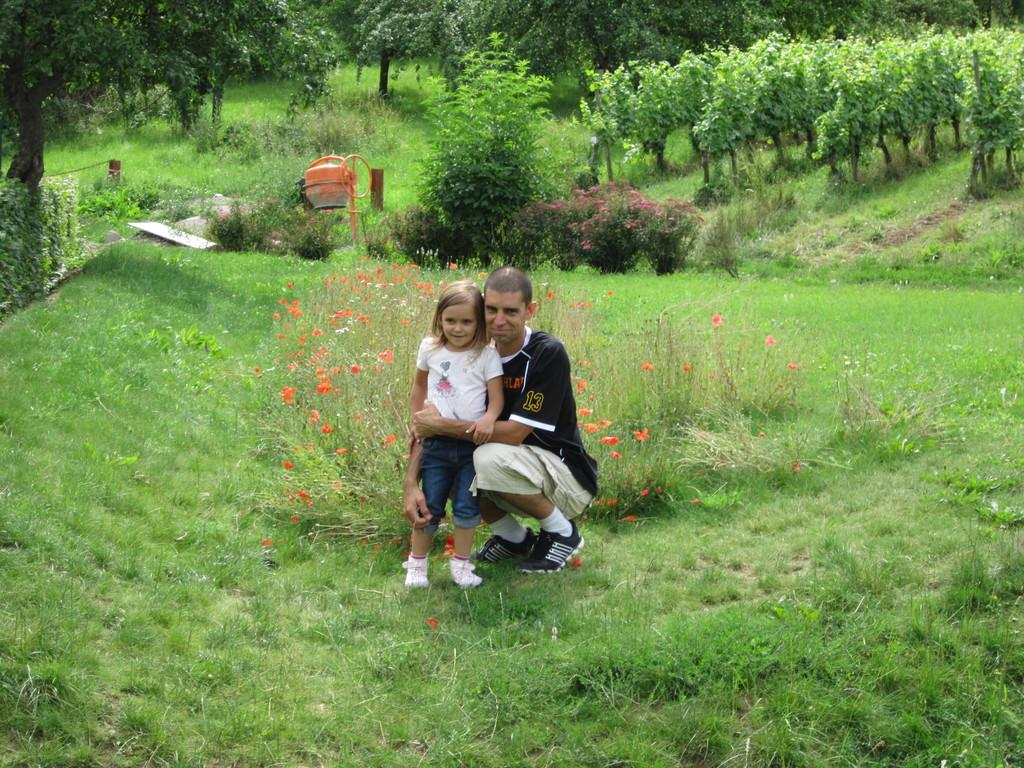How many people are in the image? There are two persons in the image. What type of natural elements can be seen in the image? There are trees, plants, flowers, and grass in the image. What is present on the ground in the image? There are other objects on the ground in the image. What type of apparel is the cobweb wearing in the image? There is no cobweb present in the image, and therefore no apparel can be associated with it. 